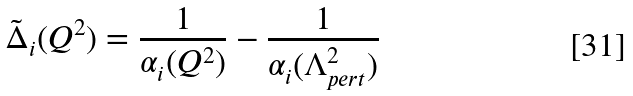<formula> <loc_0><loc_0><loc_500><loc_500>\tilde { \Delta } _ { i } ( Q ^ { 2 } ) = \frac { 1 } { \alpha _ { i } ( Q ^ { 2 } ) } - \frac { 1 } { \alpha _ { i } ( \Lambda _ { p e r t } ^ { 2 } ) }</formula> 